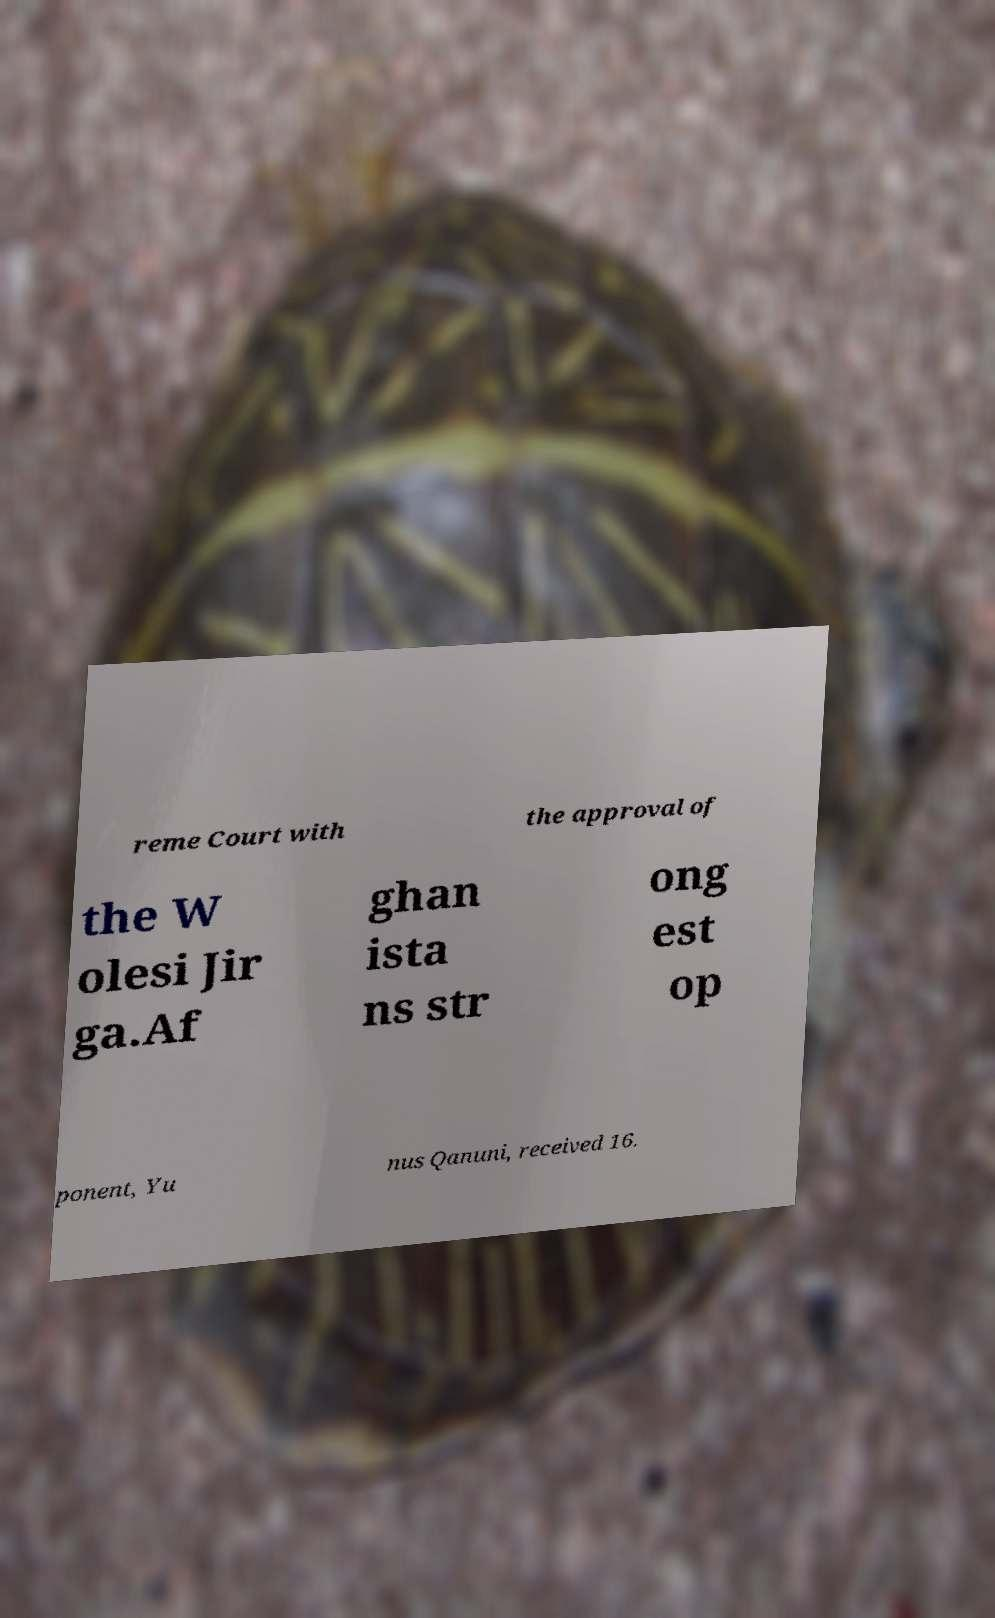Can you accurately transcribe the text from the provided image for me? reme Court with the approval of the W olesi Jir ga.Af ghan ista ns str ong est op ponent, Yu nus Qanuni, received 16. 